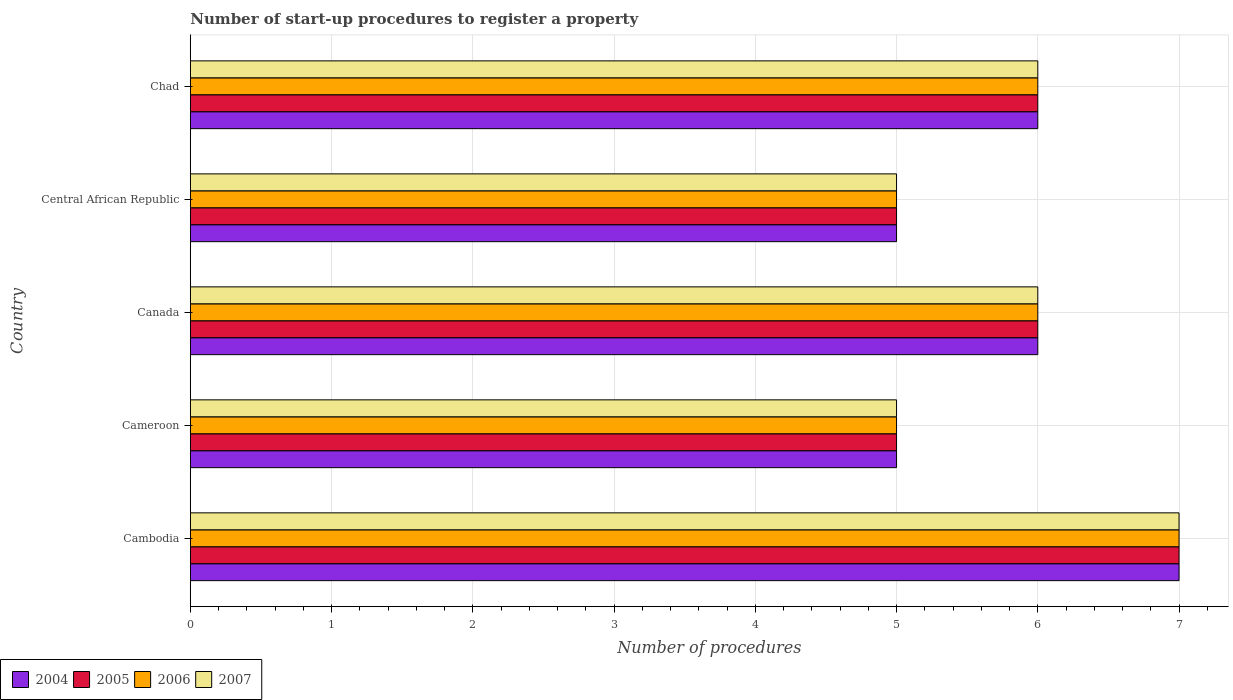How many different coloured bars are there?
Keep it short and to the point. 4. How many groups of bars are there?
Keep it short and to the point. 5. What is the label of the 5th group of bars from the top?
Offer a terse response. Cambodia. What is the number of procedures required to register a property in 2005 in Cambodia?
Your answer should be compact. 7. Across all countries, what is the minimum number of procedures required to register a property in 2007?
Your response must be concise. 5. In which country was the number of procedures required to register a property in 2006 maximum?
Keep it short and to the point. Cambodia. In which country was the number of procedures required to register a property in 2006 minimum?
Give a very brief answer. Cameroon. What is the total number of procedures required to register a property in 2006 in the graph?
Keep it short and to the point. 29. What is the difference between the number of procedures required to register a property in 2007 in Cambodia and that in Canada?
Your answer should be compact. 1. What is the difference between the number of procedures required to register a property in 2005 in Cameroon and the number of procedures required to register a property in 2004 in Central African Republic?
Give a very brief answer. 0. What is the difference between the number of procedures required to register a property in 2007 and number of procedures required to register a property in 2005 in Canada?
Offer a very short reply. 0. In how many countries, is the number of procedures required to register a property in 2006 greater than 2.8 ?
Your answer should be very brief. 5. What is the ratio of the number of procedures required to register a property in 2007 in Cambodia to that in Central African Republic?
Your response must be concise. 1.4. Is the sum of the number of procedures required to register a property in 2006 in Cambodia and Canada greater than the maximum number of procedures required to register a property in 2007 across all countries?
Keep it short and to the point. Yes. Is it the case that in every country, the sum of the number of procedures required to register a property in 2007 and number of procedures required to register a property in 2006 is greater than the sum of number of procedures required to register a property in 2005 and number of procedures required to register a property in 2004?
Make the answer very short. No. What does the 1st bar from the bottom in Cameroon represents?
Give a very brief answer. 2004. Are all the bars in the graph horizontal?
Offer a terse response. Yes. Does the graph contain any zero values?
Your response must be concise. No. How many legend labels are there?
Provide a short and direct response. 4. How are the legend labels stacked?
Your response must be concise. Horizontal. What is the title of the graph?
Keep it short and to the point. Number of start-up procedures to register a property. Does "2003" appear as one of the legend labels in the graph?
Provide a short and direct response. No. What is the label or title of the X-axis?
Offer a terse response. Number of procedures. What is the Number of procedures in 2006 in Cambodia?
Offer a very short reply. 7. What is the Number of procedures of 2007 in Cambodia?
Give a very brief answer. 7. What is the Number of procedures in 2006 in Cameroon?
Your answer should be very brief. 5. What is the Number of procedures of 2005 in Canada?
Your response must be concise. 6. What is the Number of procedures in 2006 in Canada?
Make the answer very short. 6. What is the Number of procedures in 2007 in Canada?
Offer a terse response. 6. What is the Number of procedures in 2005 in Central African Republic?
Your response must be concise. 5. What is the Number of procedures in 2007 in Central African Republic?
Give a very brief answer. 5. What is the Number of procedures of 2004 in Chad?
Provide a succinct answer. 6. What is the Number of procedures in 2006 in Chad?
Provide a short and direct response. 6. Across all countries, what is the maximum Number of procedures of 2004?
Give a very brief answer. 7. Across all countries, what is the maximum Number of procedures in 2005?
Keep it short and to the point. 7. What is the total Number of procedures of 2006 in the graph?
Offer a terse response. 29. What is the difference between the Number of procedures in 2006 in Cambodia and that in Cameroon?
Your answer should be compact. 2. What is the difference between the Number of procedures in 2006 in Cambodia and that in Canada?
Offer a very short reply. 1. What is the difference between the Number of procedures in 2005 in Cambodia and that in Central African Republic?
Provide a short and direct response. 2. What is the difference between the Number of procedures of 2006 in Cambodia and that in Central African Republic?
Give a very brief answer. 2. What is the difference between the Number of procedures of 2007 in Cambodia and that in Central African Republic?
Give a very brief answer. 2. What is the difference between the Number of procedures in 2004 in Cambodia and that in Chad?
Keep it short and to the point. 1. What is the difference between the Number of procedures of 2005 in Cambodia and that in Chad?
Your answer should be compact. 1. What is the difference between the Number of procedures of 2004 in Cameroon and that in Canada?
Provide a short and direct response. -1. What is the difference between the Number of procedures of 2005 in Cameroon and that in Canada?
Ensure brevity in your answer.  -1. What is the difference between the Number of procedures in 2007 in Cameroon and that in Canada?
Give a very brief answer. -1. What is the difference between the Number of procedures in 2004 in Cameroon and that in Central African Republic?
Your response must be concise. 0. What is the difference between the Number of procedures of 2005 in Cameroon and that in Central African Republic?
Your response must be concise. 0. What is the difference between the Number of procedures in 2004 in Cameroon and that in Chad?
Provide a short and direct response. -1. What is the difference between the Number of procedures in 2005 in Cameroon and that in Chad?
Offer a very short reply. -1. What is the difference between the Number of procedures in 2007 in Cameroon and that in Chad?
Give a very brief answer. -1. What is the difference between the Number of procedures in 2005 in Canada and that in Central African Republic?
Your answer should be compact. 1. What is the difference between the Number of procedures of 2007 in Canada and that in Central African Republic?
Ensure brevity in your answer.  1. What is the difference between the Number of procedures in 2005 in Canada and that in Chad?
Provide a succinct answer. 0. What is the difference between the Number of procedures of 2004 in Central African Republic and that in Chad?
Your answer should be very brief. -1. What is the difference between the Number of procedures of 2005 in Central African Republic and that in Chad?
Your response must be concise. -1. What is the difference between the Number of procedures of 2006 in Central African Republic and that in Chad?
Give a very brief answer. -1. What is the difference between the Number of procedures in 2007 in Central African Republic and that in Chad?
Your answer should be compact. -1. What is the difference between the Number of procedures in 2006 in Cambodia and the Number of procedures in 2007 in Cameroon?
Ensure brevity in your answer.  2. What is the difference between the Number of procedures of 2004 in Cambodia and the Number of procedures of 2006 in Canada?
Ensure brevity in your answer.  1. What is the difference between the Number of procedures of 2004 in Cambodia and the Number of procedures of 2005 in Central African Republic?
Offer a terse response. 2. What is the difference between the Number of procedures of 2005 in Cambodia and the Number of procedures of 2006 in Central African Republic?
Offer a very short reply. 2. What is the difference between the Number of procedures in 2004 in Cambodia and the Number of procedures in 2005 in Chad?
Ensure brevity in your answer.  1. What is the difference between the Number of procedures in 2004 in Cambodia and the Number of procedures in 2007 in Chad?
Your answer should be compact. 1. What is the difference between the Number of procedures of 2005 in Cambodia and the Number of procedures of 2006 in Chad?
Keep it short and to the point. 1. What is the difference between the Number of procedures in 2005 in Cambodia and the Number of procedures in 2007 in Chad?
Provide a succinct answer. 1. What is the difference between the Number of procedures of 2004 in Cameroon and the Number of procedures of 2006 in Canada?
Your response must be concise. -1. What is the difference between the Number of procedures of 2004 in Cameroon and the Number of procedures of 2007 in Canada?
Ensure brevity in your answer.  -1. What is the difference between the Number of procedures in 2005 in Cameroon and the Number of procedures in 2006 in Canada?
Ensure brevity in your answer.  -1. What is the difference between the Number of procedures of 2006 in Cameroon and the Number of procedures of 2007 in Canada?
Offer a very short reply. -1. What is the difference between the Number of procedures in 2004 in Cameroon and the Number of procedures in 2006 in Central African Republic?
Your answer should be very brief. 0. What is the difference between the Number of procedures of 2004 in Cameroon and the Number of procedures of 2007 in Central African Republic?
Keep it short and to the point. 0. What is the difference between the Number of procedures of 2005 in Cameroon and the Number of procedures of 2006 in Central African Republic?
Your answer should be very brief. 0. What is the difference between the Number of procedures of 2005 in Cameroon and the Number of procedures of 2007 in Central African Republic?
Provide a succinct answer. 0. What is the difference between the Number of procedures of 2004 in Cameroon and the Number of procedures of 2005 in Chad?
Ensure brevity in your answer.  -1. What is the difference between the Number of procedures of 2006 in Cameroon and the Number of procedures of 2007 in Chad?
Your answer should be compact. -1. What is the difference between the Number of procedures of 2004 in Canada and the Number of procedures of 2005 in Central African Republic?
Offer a terse response. 1. What is the difference between the Number of procedures in 2005 in Canada and the Number of procedures in 2006 in Central African Republic?
Ensure brevity in your answer.  1. What is the difference between the Number of procedures in 2006 in Canada and the Number of procedures in 2007 in Central African Republic?
Provide a short and direct response. 1. What is the difference between the Number of procedures of 2004 in Canada and the Number of procedures of 2007 in Chad?
Your answer should be compact. 0. What is the difference between the Number of procedures in 2005 in Canada and the Number of procedures in 2006 in Chad?
Provide a short and direct response. 0. What is the difference between the Number of procedures in 2006 in Canada and the Number of procedures in 2007 in Chad?
Provide a short and direct response. 0. What is the difference between the Number of procedures of 2005 in Central African Republic and the Number of procedures of 2007 in Chad?
Your response must be concise. -1. What is the average Number of procedures of 2005 per country?
Keep it short and to the point. 5.8. What is the difference between the Number of procedures in 2004 and Number of procedures in 2007 in Cambodia?
Your answer should be very brief. 0. What is the difference between the Number of procedures in 2004 and Number of procedures in 2007 in Cameroon?
Your answer should be compact. 0. What is the difference between the Number of procedures in 2005 and Number of procedures in 2006 in Cameroon?
Provide a short and direct response. 0. What is the difference between the Number of procedures in 2004 and Number of procedures in 2005 in Canada?
Keep it short and to the point. 0. What is the difference between the Number of procedures of 2005 and Number of procedures of 2007 in Canada?
Your answer should be very brief. 0. What is the difference between the Number of procedures of 2006 and Number of procedures of 2007 in Canada?
Offer a terse response. 0. What is the difference between the Number of procedures of 2004 and Number of procedures of 2005 in Central African Republic?
Keep it short and to the point. 0. What is the difference between the Number of procedures of 2004 and Number of procedures of 2006 in Central African Republic?
Offer a terse response. 0. What is the difference between the Number of procedures of 2005 and Number of procedures of 2006 in Central African Republic?
Provide a succinct answer. 0. What is the difference between the Number of procedures of 2004 and Number of procedures of 2006 in Chad?
Ensure brevity in your answer.  0. What is the difference between the Number of procedures in 2005 and Number of procedures in 2006 in Chad?
Your response must be concise. 0. What is the difference between the Number of procedures of 2005 and Number of procedures of 2007 in Chad?
Keep it short and to the point. 0. What is the difference between the Number of procedures in 2006 and Number of procedures in 2007 in Chad?
Give a very brief answer. 0. What is the ratio of the Number of procedures of 2006 in Cambodia to that in Cameroon?
Provide a short and direct response. 1.4. What is the ratio of the Number of procedures of 2005 in Cambodia to that in Canada?
Your answer should be very brief. 1.17. What is the ratio of the Number of procedures of 2006 in Cambodia to that in Canada?
Your answer should be very brief. 1.17. What is the ratio of the Number of procedures of 2007 in Cambodia to that in Canada?
Keep it short and to the point. 1.17. What is the ratio of the Number of procedures in 2005 in Cambodia to that in Central African Republic?
Give a very brief answer. 1.4. What is the ratio of the Number of procedures in 2006 in Cambodia to that in Central African Republic?
Provide a short and direct response. 1.4. What is the ratio of the Number of procedures in 2004 in Cambodia to that in Chad?
Make the answer very short. 1.17. What is the ratio of the Number of procedures in 2006 in Cambodia to that in Chad?
Provide a short and direct response. 1.17. What is the ratio of the Number of procedures of 2007 in Cambodia to that in Chad?
Ensure brevity in your answer.  1.17. What is the ratio of the Number of procedures of 2005 in Cameroon to that in Canada?
Provide a succinct answer. 0.83. What is the ratio of the Number of procedures in 2006 in Cameroon to that in Canada?
Give a very brief answer. 0.83. What is the ratio of the Number of procedures in 2004 in Cameroon to that in Central African Republic?
Provide a succinct answer. 1. What is the ratio of the Number of procedures of 2007 in Cameroon to that in Chad?
Make the answer very short. 0.83. What is the ratio of the Number of procedures in 2005 in Canada to that in Chad?
Offer a terse response. 1. What is the ratio of the Number of procedures in 2007 in Canada to that in Chad?
Give a very brief answer. 1. What is the ratio of the Number of procedures in 2004 in Central African Republic to that in Chad?
Your response must be concise. 0.83. What is the ratio of the Number of procedures of 2006 in Central African Republic to that in Chad?
Your response must be concise. 0.83. What is the ratio of the Number of procedures of 2007 in Central African Republic to that in Chad?
Your answer should be very brief. 0.83. What is the difference between the highest and the second highest Number of procedures in 2005?
Keep it short and to the point. 1. What is the difference between the highest and the second highest Number of procedures in 2007?
Ensure brevity in your answer.  1. What is the difference between the highest and the lowest Number of procedures of 2006?
Offer a very short reply. 2. 